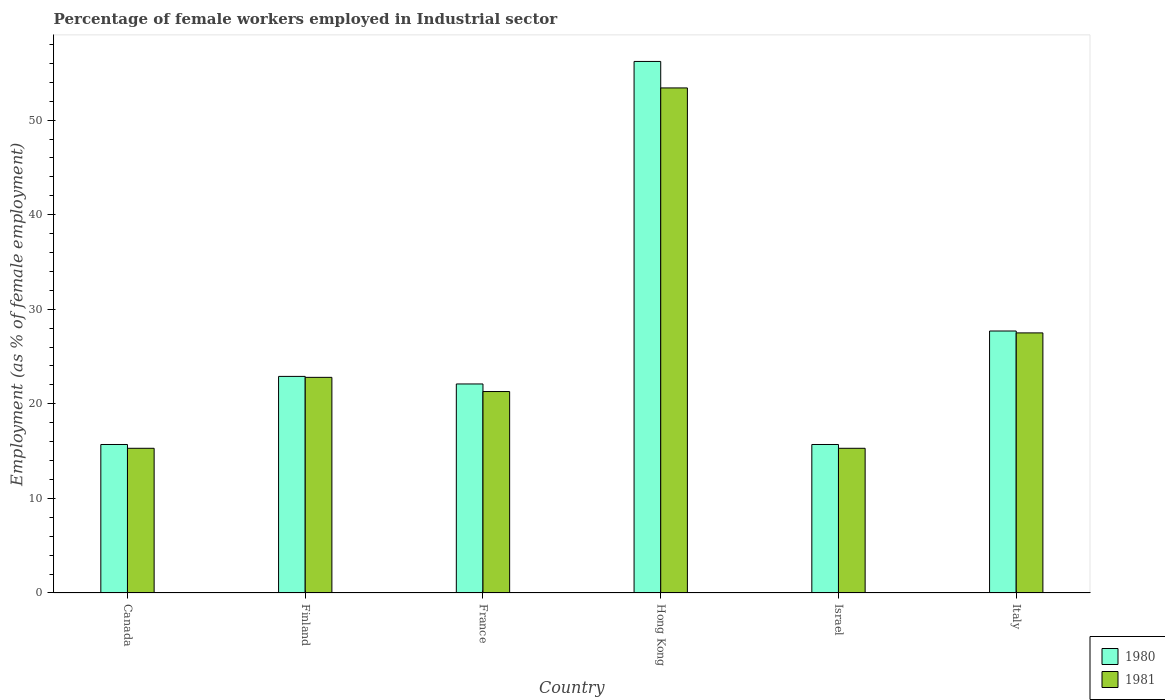How many different coloured bars are there?
Your answer should be very brief. 2. Are the number of bars per tick equal to the number of legend labels?
Your answer should be very brief. Yes. How many bars are there on the 2nd tick from the right?
Offer a very short reply. 2. In how many cases, is the number of bars for a given country not equal to the number of legend labels?
Offer a very short reply. 0. What is the percentage of females employed in Industrial sector in 1981 in Israel?
Give a very brief answer. 15.3. Across all countries, what is the maximum percentage of females employed in Industrial sector in 1981?
Keep it short and to the point. 53.4. Across all countries, what is the minimum percentage of females employed in Industrial sector in 1980?
Make the answer very short. 15.7. In which country was the percentage of females employed in Industrial sector in 1980 maximum?
Provide a short and direct response. Hong Kong. In which country was the percentage of females employed in Industrial sector in 1980 minimum?
Your answer should be very brief. Canada. What is the total percentage of females employed in Industrial sector in 1981 in the graph?
Your answer should be compact. 155.6. What is the difference between the percentage of females employed in Industrial sector in 1980 in France and that in Italy?
Offer a very short reply. -5.6. What is the difference between the percentage of females employed in Industrial sector in 1980 in France and the percentage of females employed in Industrial sector in 1981 in Italy?
Your response must be concise. -5.4. What is the average percentage of females employed in Industrial sector in 1981 per country?
Offer a terse response. 25.93. What is the difference between the percentage of females employed in Industrial sector of/in 1980 and percentage of females employed in Industrial sector of/in 1981 in Canada?
Give a very brief answer. 0.4. Is the percentage of females employed in Industrial sector in 1981 in Canada less than that in Italy?
Make the answer very short. Yes. Is the difference between the percentage of females employed in Industrial sector in 1980 in France and Italy greater than the difference between the percentage of females employed in Industrial sector in 1981 in France and Italy?
Offer a terse response. Yes. What is the difference between the highest and the second highest percentage of females employed in Industrial sector in 1980?
Provide a succinct answer. 28.5. What is the difference between the highest and the lowest percentage of females employed in Industrial sector in 1980?
Your response must be concise. 40.5. In how many countries, is the percentage of females employed in Industrial sector in 1980 greater than the average percentage of females employed in Industrial sector in 1980 taken over all countries?
Offer a very short reply. 2. What does the 1st bar from the right in Italy represents?
Offer a terse response. 1981. How many bars are there?
Offer a very short reply. 12. Are all the bars in the graph horizontal?
Offer a very short reply. No. How many countries are there in the graph?
Keep it short and to the point. 6. What is the difference between two consecutive major ticks on the Y-axis?
Your response must be concise. 10. What is the title of the graph?
Your answer should be very brief. Percentage of female workers employed in Industrial sector. What is the label or title of the Y-axis?
Give a very brief answer. Employment (as % of female employment). What is the Employment (as % of female employment) in 1980 in Canada?
Ensure brevity in your answer.  15.7. What is the Employment (as % of female employment) in 1981 in Canada?
Provide a succinct answer. 15.3. What is the Employment (as % of female employment) in 1980 in Finland?
Provide a short and direct response. 22.9. What is the Employment (as % of female employment) of 1981 in Finland?
Ensure brevity in your answer.  22.8. What is the Employment (as % of female employment) in 1980 in France?
Make the answer very short. 22.1. What is the Employment (as % of female employment) in 1981 in France?
Provide a succinct answer. 21.3. What is the Employment (as % of female employment) in 1980 in Hong Kong?
Your response must be concise. 56.2. What is the Employment (as % of female employment) in 1981 in Hong Kong?
Provide a short and direct response. 53.4. What is the Employment (as % of female employment) in 1980 in Israel?
Ensure brevity in your answer.  15.7. What is the Employment (as % of female employment) of 1981 in Israel?
Provide a succinct answer. 15.3. What is the Employment (as % of female employment) of 1980 in Italy?
Your answer should be very brief. 27.7. What is the Employment (as % of female employment) of 1981 in Italy?
Offer a terse response. 27.5. Across all countries, what is the maximum Employment (as % of female employment) of 1980?
Your response must be concise. 56.2. Across all countries, what is the maximum Employment (as % of female employment) in 1981?
Provide a short and direct response. 53.4. Across all countries, what is the minimum Employment (as % of female employment) in 1980?
Give a very brief answer. 15.7. Across all countries, what is the minimum Employment (as % of female employment) of 1981?
Offer a very short reply. 15.3. What is the total Employment (as % of female employment) of 1980 in the graph?
Keep it short and to the point. 160.3. What is the total Employment (as % of female employment) of 1981 in the graph?
Your answer should be compact. 155.6. What is the difference between the Employment (as % of female employment) in 1980 in Canada and that in Finland?
Make the answer very short. -7.2. What is the difference between the Employment (as % of female employment) in 1980 in Canada and that in Hong Kong?
Provide a succinct answer. -40.5. What is the difference between the Employment (as % of female employment) in 1981 in Canada and that in Hong Kong?
Your answer should be compact. -38.1. What is the difference between the Employment (as % of female employment) of 1980 in Finland and that in France?
Offer a very short reply. 0.8. What is the difference between the Employment (as % of female employment) of 1981 in Finland and that in France?
Your answer should be compact. 1.5. What is the difference between the Employment (as % of female employment) in 1980 in Finland and that in Hong Kong?
Your answer should be compact. -33.3. What is the difference between the Employment (as % of female employment) of 1981 in Finland and that in Hong Kong?
Offer a terse response. -30.6. What is the difference between the Employment (as % of female employment) in 1980 in Finland and that in Italy?
Provide a succinct answer. -4.8. What is the difference between the Employment (as % of female employment) of 1980 in France and that in Hong Kong?
Give a very brief answer. -34.1. What is the difference between the Employment (as % of female employment) in 1981 in France and that in Hong Kong?
Your answer should be very brief. -32.1. What is the difference between the Employment (as % of female employment) in 1980 in France and that in Italy?
Your response must be concise. -5.6. What is the difference between the Employment (as % of female employment) in 1980 in Hong Kong and that in Israel?
Your answer should be compact. 40.5. What is the difference between the Employment (as % of female employment) of 1981 in Hong Kong and that in Israel?
Provide a short and direct response. 38.1. What is the difference between the Employment (as % of female employment) of 1981 in Hong Kong and that in Italy?
Give a very brief answer. 25.9. What is the difference between the Employment (as % of female employment) of 1980 in Israel and that in Italy?
Offer a terse response. -12. What is the difference between the Employment (as % of female employment) in 1980 in Canada and the Employment (as % of female employment) in 1981 in Hong Kong?
Your response must be concise. -37.7. What is the difference between the Employment (as % of female employment) in 1980 in Finland and the Employment (as % of female employment) in 1981 in France?
Offer a terse response. 1.6. What is the difference between the Employment (as % of female employment) of 1980 in Finland and the Employment (as % of female employment) of 1981 in Hong Kong?
Your answer should be compact. -30.5. What is the difference between the Employment (as % of female employment) of 1980 in Finland and the Employment (as % of female employment) of 1981 in Israel?
Your answer should be very brief. 7.6. What is the difference between the Employment (as % of female employment) in 1980 in Finland and the Employment (as % of female employment) in 1981 in Italy?
Your answer should be very brief. -4.6. What is the difference between the Employment (as % of female employment) in 1980 in France and the Employment (as % of female employment) in 1981 in Hong Kong?
Ensure brevity in your answer.  -31.3. What is the difference between the Employment (as % of female employment) of 1980 in France and the Employment (as % of female employment) of 1981 in Italy?
Offer a very short reply. -5.4. What is the difference between the Employment (as % of female employment) of 1980 in Hong Kong and the Employment (as % of female employment) of 1981 in Israel?
Offer a terse response. 40.9. What is the difference between the Employment (as % of female employment) of 1980 in Hong Kong and the Employment (as % of female employment) of 1981 in Italy?
Your answer should be compact. 28.7. What is the average Employment (as % of female employment) of 1980 per country?
Your answer should be compact. 26.72. What is the average Employment (as % of female employment) of 1981 per country?
Make the answer very short. 25.93. What is the difference between the Employment (as % of female employment) of 1980 and Employment (as % of female employment) of 1981 in Canada?
Provide a short and direct response. 0.4. What is the difference between the Employment (as % of female employment) of 1980 and Employment (as % of female employment) of 1981 in France?
Provide a short and direct response. 0.8. What is the ratio of the Employment (as % of female employment) of 1980 in Canada to that in Finland?
Your answer should be compact. 0.69. What is the ratio of the Employment (as % of female employment) of 1981 in Canada to that in Finland?
Make the answer very short. 0.67. What is the ratio of the Employment (as % of female employment) in 1980 in Canada to that in France?
Make the answer very short. 0.71. What is the ratio of the Employment (as % of female employment) of 1981 in Canada to that in France?
Your answer should be compact. 0.72. What is the ratio of the Employment (as % of female employment) of 1980 in Canada to that in Hong Kong?
Keep it short and to the point. 0.28. What is the ratio of the Employment (as % of female employment) of 1981 in Canada to that in Hong Kong?
Offer a terse response. 0.29. What is the ratio of the Employment (as % of female employment) of 1980 in Canada to that in Italy?
Ensure brevity in your answer.  0.57. What is the ratio of the Employment (as % of female employment) of 1981 in Canada to that in Italy?
Make the answer very short. 0.56. What is the ratio of the Employment (as % of female employment) of 1980 in Finland to that in France?
Make the answer very short. 1.04. What is the ratio of the Employment (as % of female employment) of 1981 in Finland to that in France?
Ensure brevity in your answer.  1.07. What is the ratio of the Employment (as % of female employment) in 1980 in Finland to that in Hong Kong?
Offer a very short reply. 0.41. What is the ratio of the Employment (as % of female employment) in 1981 in Finland to that in Hong Kong?
Keep it short and to the point. 0.43. What is the ratio of the Employment (as % of female employment) in 1980 in Finland to that in Israel?
Ensure brevity in your answer.  1.46. What is the ratio of the Employment (as % of female employment) of 1981 in Finland to that in Israel?
Your answer should be compact. 1.49. What is the ratio of the Employment (as % of female employment) in 1980 in Finland to that in Italy?
Provide a succinct answer. 0.83. What is the ratio of the Employment (as % of female employment) of 1981 in Finland to that in Italy?
Provide a short and direct response. 0.83. What is the ratio of the Employment (as % of female employment) of 1980 in France to that in Hong Kong?
Provide a succinct answer. 0.39. What is the ratio of the Employment (as % of female employment) of 1981 in France to that in Hong Kong?
Give a very brief answer. 0.4. What is the ratio of the Employment (as % of female employment) in 1980 in France to that in Israel?
Your response must be concise. 1.41. What is the ratio of the Employment (as % of female employment) of 1981 in France to that in Israel?
Make the answer very short. 1.39. What is the ratio of the Employment (as % of female employment) of 1980 in France to that in Italy?
Offer a very short reply. 0.8. What is the ratio of the Employment (as % of female employment) in 1981 in France to that in Italy?
Keep it short and to the point. 0.77. What is the ratio of the Employment (as % of female employment) of 1980 in Hong Kong to that in Israel?
Provide a short and direct response. 3.58. What is the ratio of the Employment (as % of female employment) in 1981 in Hong Kong to that in Israel?
Offer a terse response. 3.49. What is the ratio of the Employment (as % of female employment) of 1980 in Hong Kong to that in Italy?
Ensure brevity in your answer.  2.03. What is the ratio of the Employment (as % of female employment) of 1981 in Hong Kong to that in Italy?
Keep it short and to the point. 1.94. What is the ratio of the Employment (as % of female employment) of 1980 in Israel to that in Italy?
Make the answer very short. 0.57. What is the ratio of the Employment (as % of female employment) in 1981 in Israel to that in Italy?
Keep it short and to the point. 0.56. What is the difference between the highest and the second highest Employment (as % of female employment) of 1981?
Offer a very short reply. 25.9. What is the difference between the highest and the lowest Employment (as % of female employment) in 1980?
Keep it short and to the point. 40.5. What is the difference between the highest and the lowest Employment (as % of female employment) of 1981?
Make the answer very short. 38.1. 